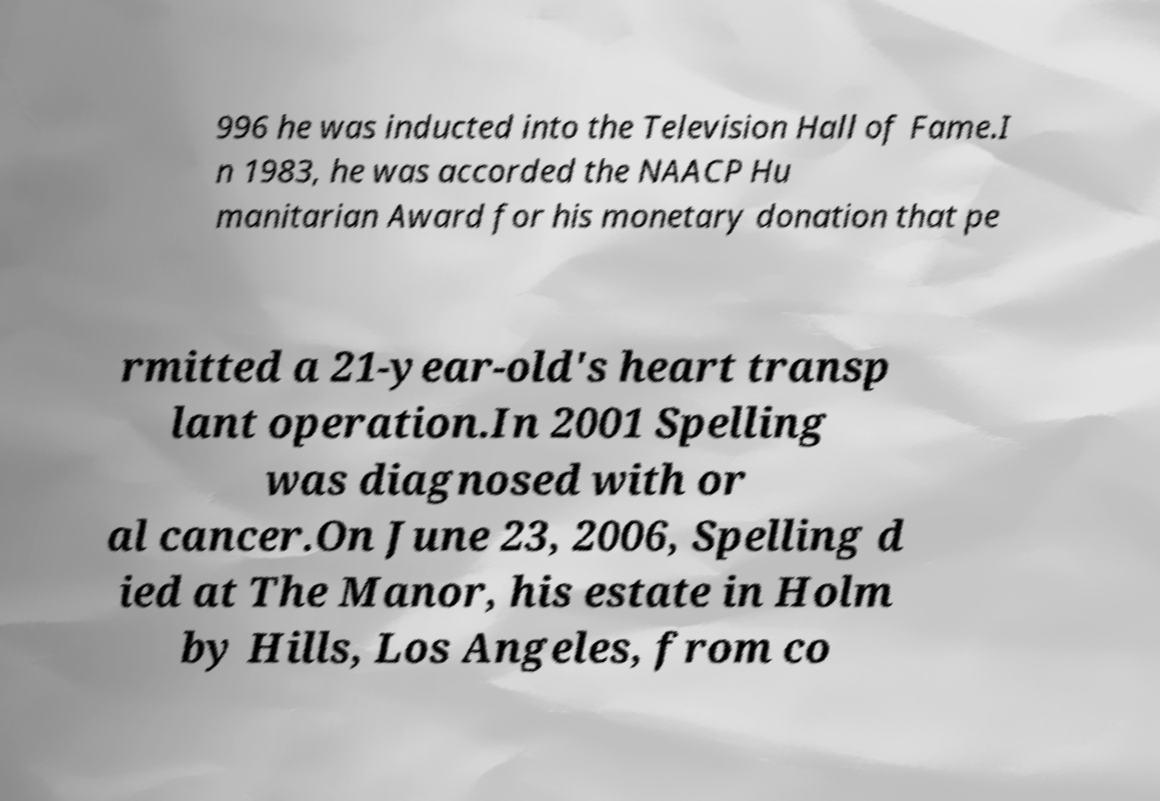For documentation purposes, I need the text within this image transcribed. Could you provide that? 996 he was inducted into the Television Hall of Fame.I n 1983, he was accorded the NAACP Hu manitarian Award for his monetary donation that pe rmitted a 21-year-old's heart transp lant operation.In 2001 Spelling was diagnosed with or al cancer.On June 23, 2006, Spelling d ied at The Manor, his estate in Holm by Hills, Los Angeles, from co 